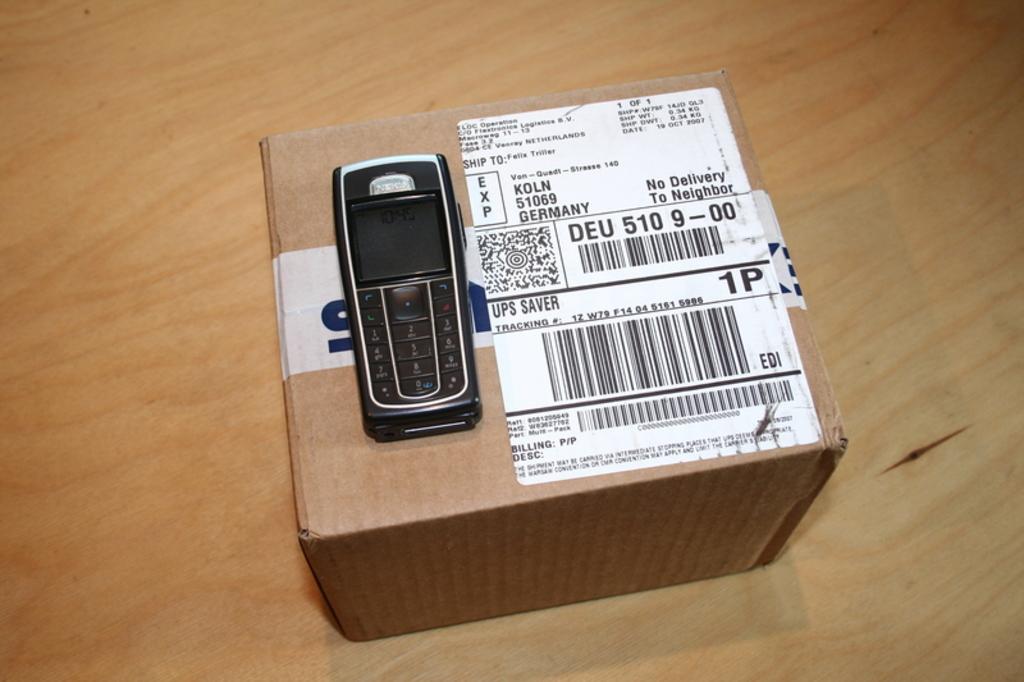Is this from germany?
Ensure brevity in your answer.  Yes. Does this say no delivery to neighbor on it?
Your answer should be compact. Yes. 